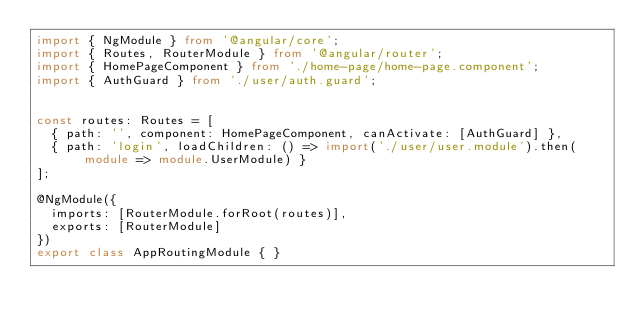Convert code to text. <code><loc_0><loc_0><loc_500><loc_500><_TypeScript_>import { NgModule } from '@angular/core';
import { Routes, RouterModule } from '@angular/router';
import { HomePageComponent } from './home-page/home-page.component';
import { AuthGuard } from './user/auth.guard';


const routes: Routes = [
  { path: '', component: HomePageComponent, canActivate: [AuthGuard] },
  { path: 'login', loadChildren: () => import('./user/user.module').then(module => module.UserModule) }
];

@NgModule({
  imports: [RouterModule.forRoot(routes)],
  exports: [RouterModule]
})
export class AppRoutingModule { }
</code> 